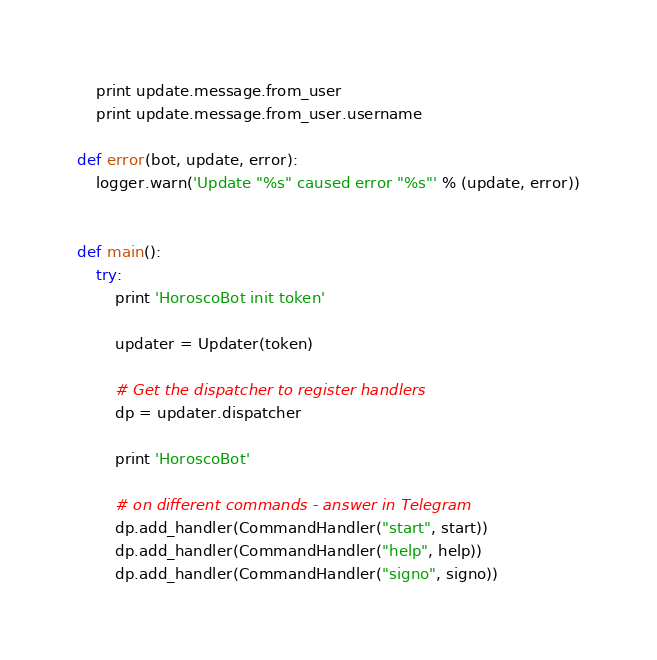<code> <loc_0><loc_0><loc_500><loc_500><_Python_>    print update.message.from_user
    print update.message.from_user.username

def error(bot, update, error):
    logger.warn('Update "%s" caused error "%s"' % (update, error))


def main():
    try:
        print 'HoroscoBot init token'

        updater = Updater(token)

        # Get the dispatcher to register handlers
        dp = updater.dispatcher

        print 'HoroscoBot'

        # on different commands - answer in Telegram
        dp.add_handler(CommandHandler("start", start))
        dp.add_handler(CommandHandler("help", help))
        dp.add_handler(CommandHandler("signo", signo))
</code> 